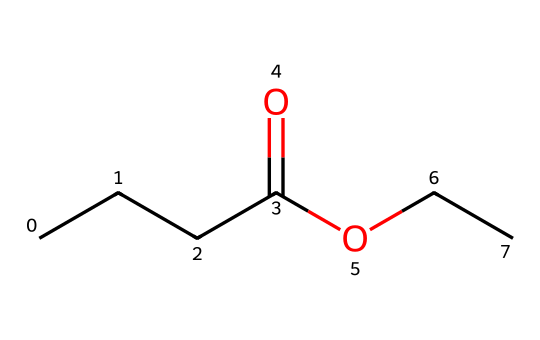How many carbon atoms are in this ester? The SMILES representation shows the presence of four carbon atoms in the chain (CCCC). Counting the carbon atoms, we see four individual carbon symbols in the structure.
Answer: four What functional groups are present in this structure? This structure contains a carboxylate group (indicated by the -OCC portion, which suggests an ester linkage) and an alkyl group. The -O and -C(=O) arrangement signifies the ester.
Answer: ester What is the total number of oxygen atoms in this chemical? The structure has two oxygen atoms: one within the carbonyl group (C=O) and one in the ether part (-O-). Counting these, we find two oxygen atoms total.
Answer: two Which part of the structure indicates it is an ester? The ester is indicated by the -COO- functional group, specifically the arrangement of the carbonyl (C=O) next to an oxygen atom that connects to another carbon atom. This is characteristic of ester functional groups.
Answer: -COO- What type of flavor is associated with this ester? The chemical structure, closely resembling butyl acetate, suggests a fruity flavor profile, often associated with flavors like banana or pear. This is due to the long carbon chain.
Answer: fruity What is the degree of unsaturation in the chemical? The degree of unsaturation can be determined from the carbon atoms and the presence of the carbonyl group, which accounts for one degree of unsaturation. In this case, there is one double bond (in -C=O) and no rings, indicating one degree of unsaturation.
Answer: one 